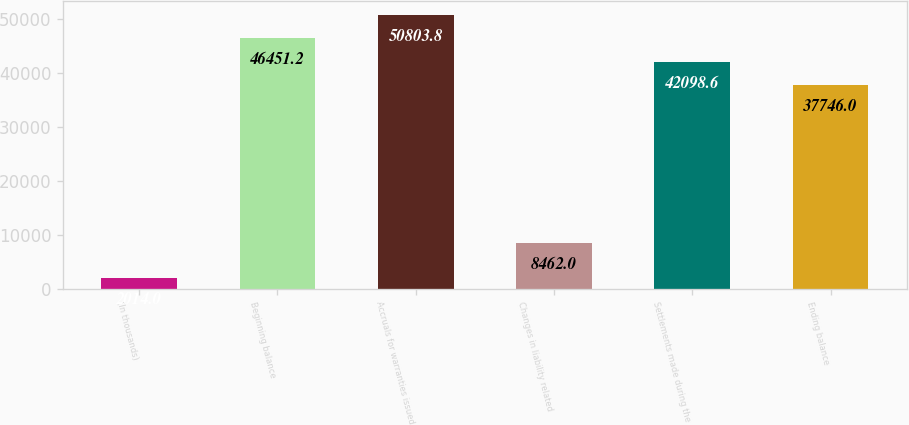Convert chart. <chart><loc_0><loc_0><loc_500><loc_500><bar_chart><fcel>(In thousands)<fcel>Beginning balance<fcel>Accruals for warranties issued<fcel>Changes in liability related<fcel>Settlements made during the<fcel>Ending balance<nl><fcel>2014<fcel>46451.2<fcel>50803.8<fcel>8462<fcel>42098.6<fcel>37746<nl></chart> 